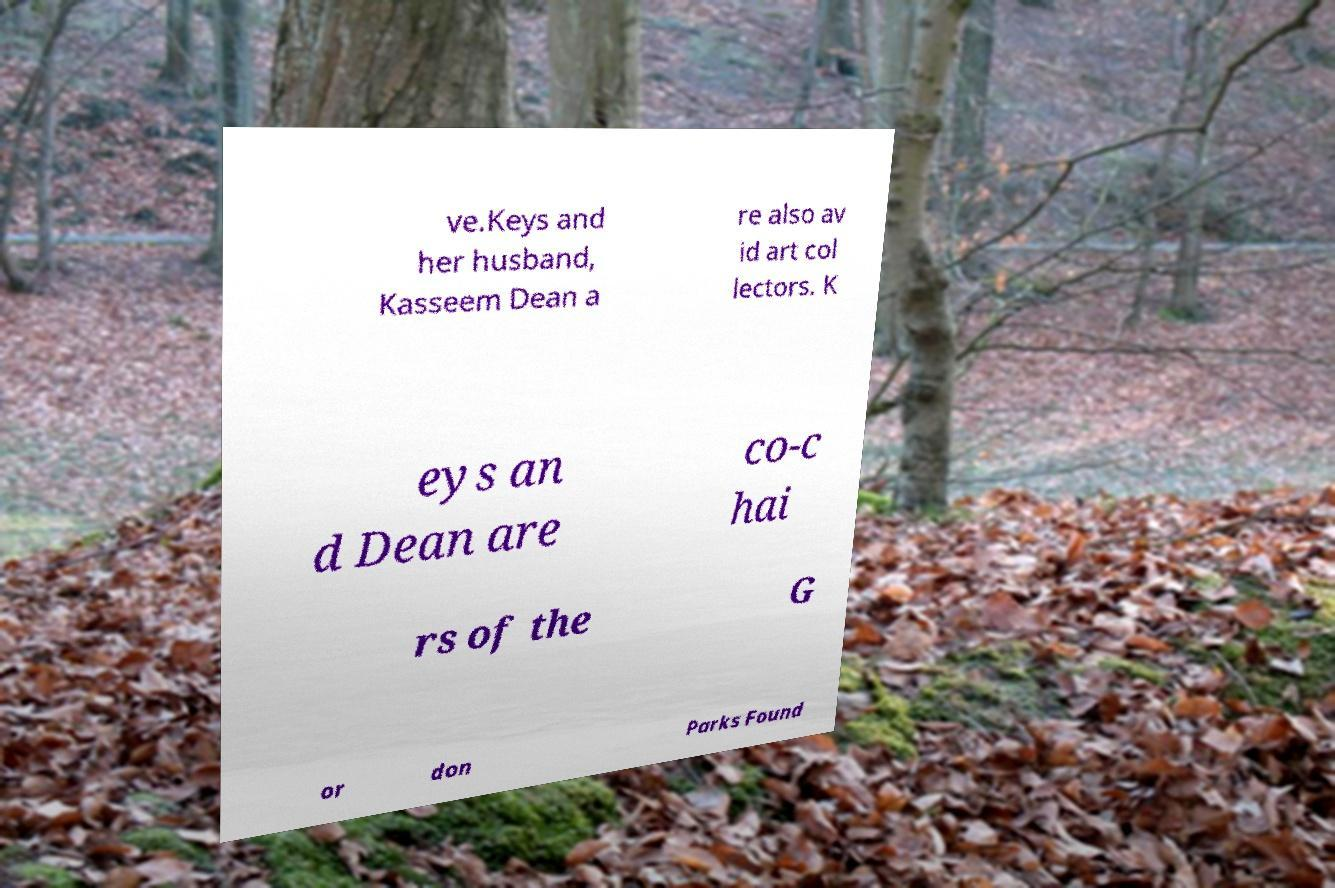Please read and relay the text visible in this image. What does it say? ve.Keys and her husband, Kasseem Dean a re also av id art col lectors. K eys an d Dean are co-c hai rs of the G or don Parks Found 